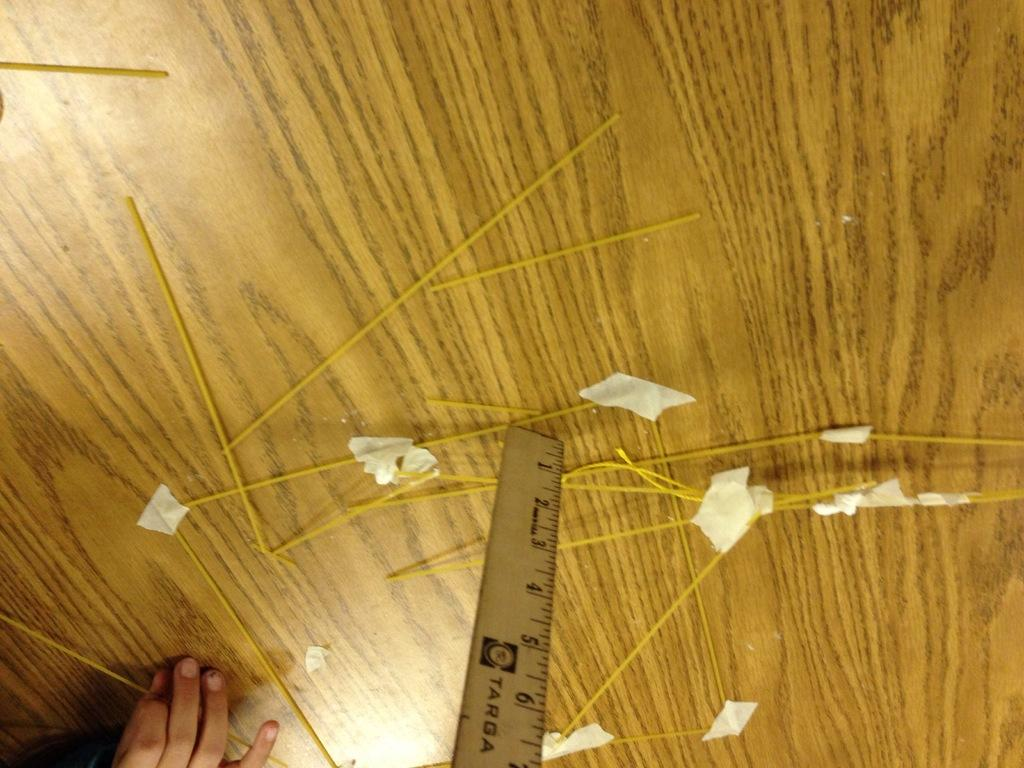Provide a one-sentence caption for the provided image. A person has raw spaghetti noodles and measuring something with a Targa ruler. 